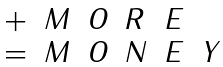<formula> <loc_0><loc_0><loc_500><loc_500>\begin{array} { l l l l l l } { + } & { M } & { O } & { R } & { E } \\ { = } & { M } & { O } & { N } & { E } & { Y } \end{array}</formula> 